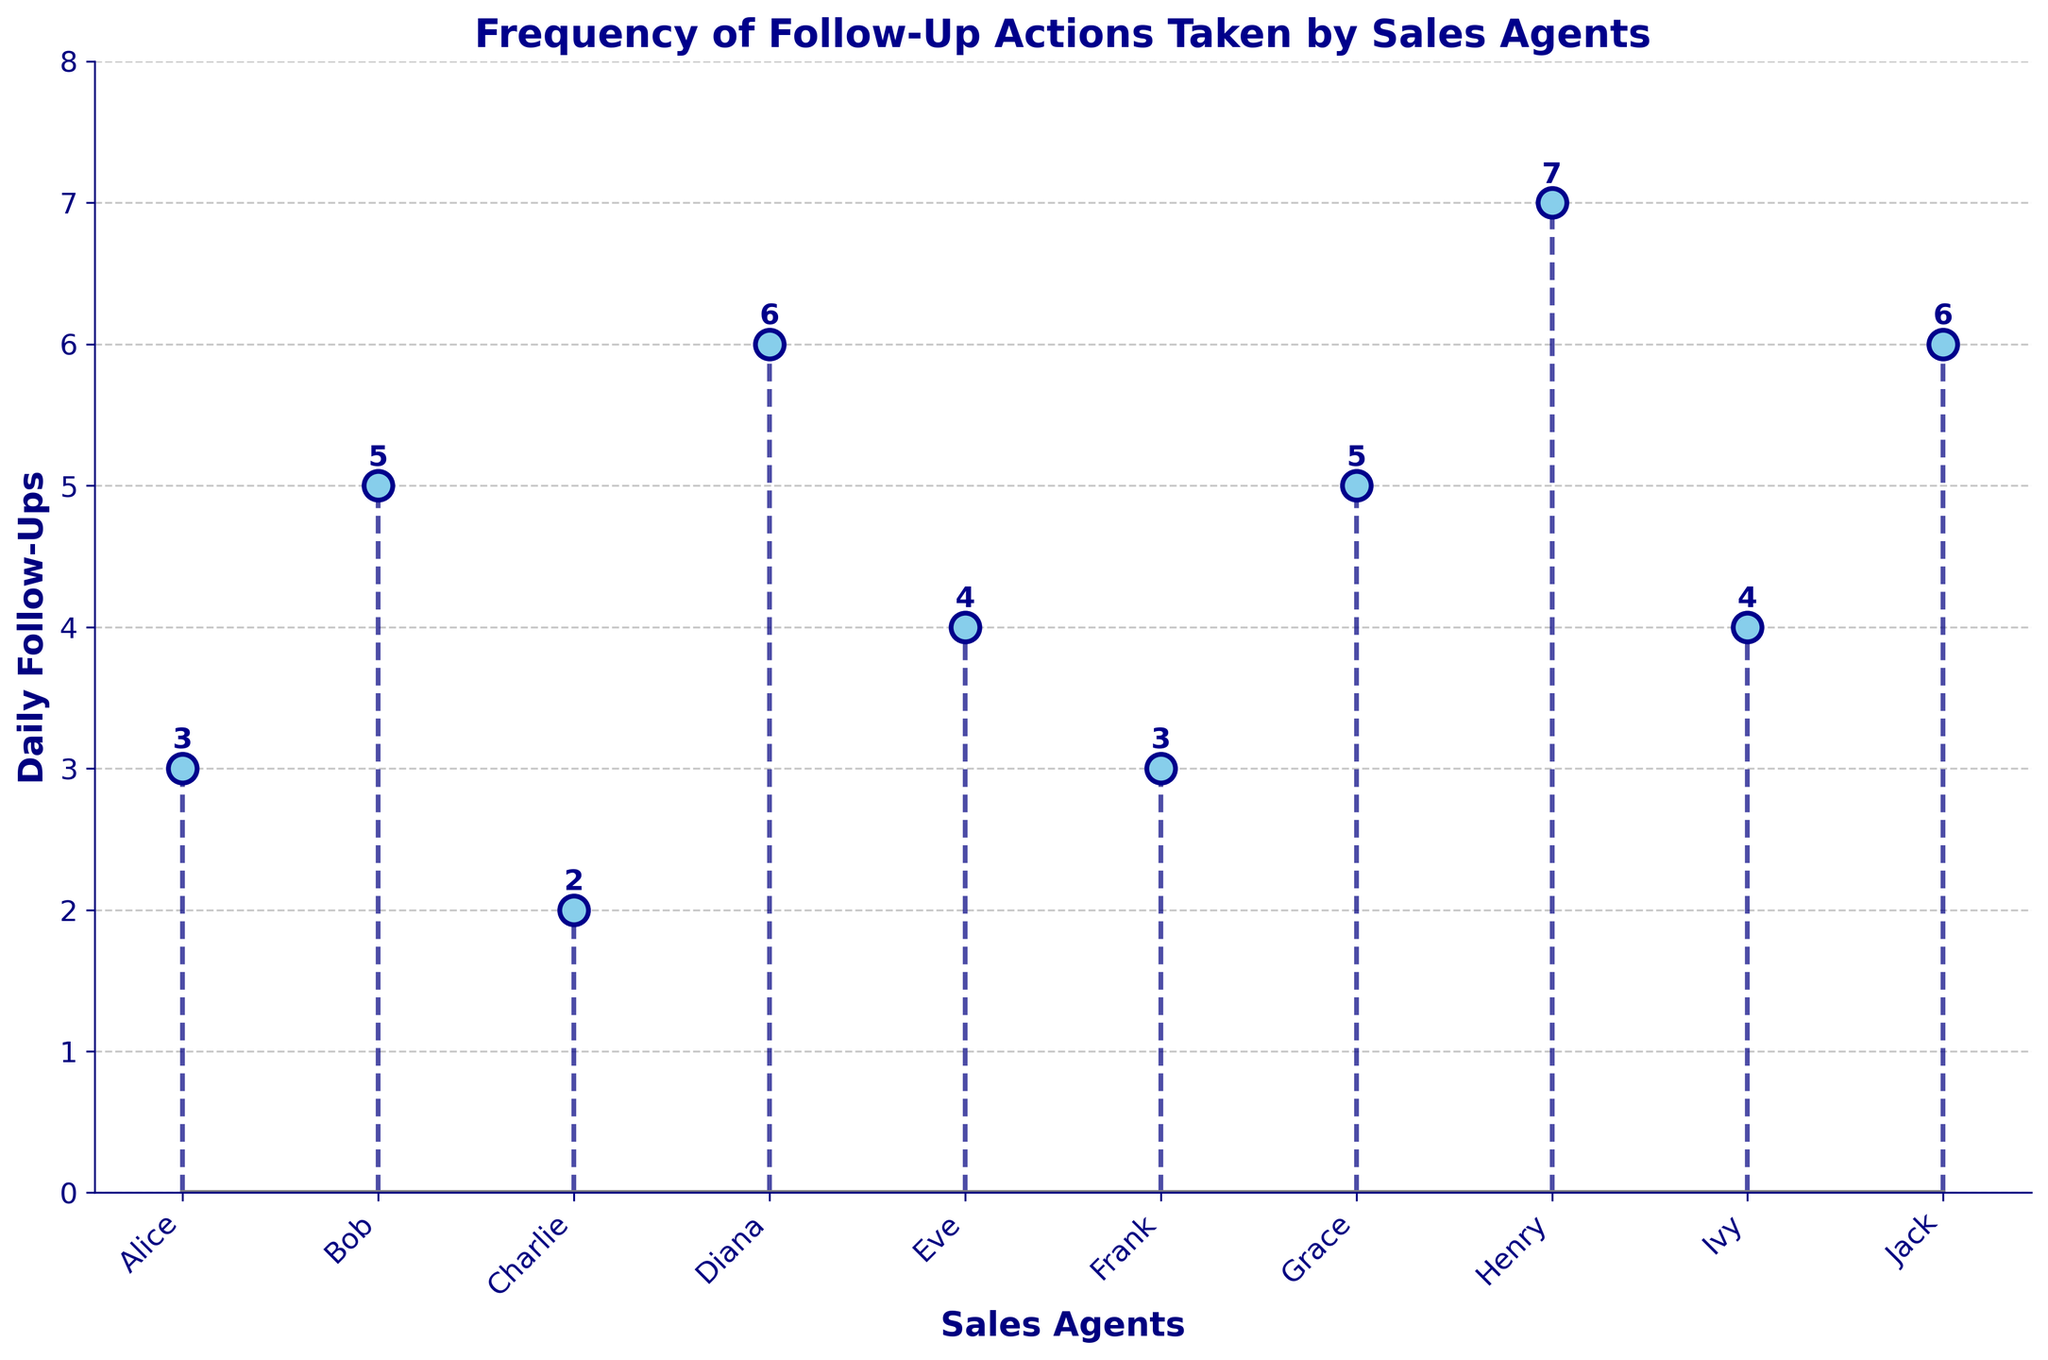What is the title of the plot? The title is located at the top of the figure and describes the overall content of the plot.
Answer: Frequency of Follow-Up Actions Taken by Sales Agents How many sales agents are shown in the plot? Count the number of individual markers or labels on the x-axis representing sales agents.
Answer: 10 Which sales agent has the highest number of daily follow-ups? Look for the tallest stem with the highest value on the y-axis and identify the corresponding sales agent on the x-axis.
Answer: Henry How many follow-ups does Diana make daily? Locate Diana on the x-axis, then follow the stem line up to the marker and read the value on the y-axis.
Answer: 6 How many sales agents have 4 or more daily follow-ups? Count the number of markers on the plot where the value is 4 or greater on the y-axis.
Answer: 6 What's the difference in daily follow-ups between Bob and Frank? Find the values for Bob and Frank on the y-axis (Bob = 5, Frank = 3) and subtract to get the difference.
Answer: 2 Which agents have the same number of daily follow-ups, and what is that number? Identify any stems that reach the same value on the y-axis and list corresponding agents and their follow-up count.
Answer: Bob and Grace (5), Ivy and Eve (4), Alice and Frank (3) What is the combined total of daily follow-ups for Alice, Charlie, and Jack? Look at the y-axis values for Alice (3), Charlie (2), and Jack (6), then sum them up: 3 + 2 + 6.
Answer: 11 What is the largest gap in daily follow-ups between any two consecutive agents on the plot? Look for the largest difference in heights between consecutive stems and compute the difference. The largest gap is between Eve (4) and Henry (7), which is 7 - 4.
Answer: 3 How do the follow-ups of agents with names starting with a vowel compare to the others? Agents starting with vowels are Alice, Eve, and Ivy with 3, 4, and 4 follow-ups respectively. Compare their average to the rest. The vowels average is (3+4+4)/3 = 3.67, and the rest average is (5+2+6+3+5+7+6)/7 = 4.86.
Answer: Lower 